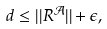Convert formula to latex. <formula><loc_0><loc_0><loc_500><loc_500>d \leq | | R ^ { \mathcal { A } } | | + \epsilon ,</formula> 